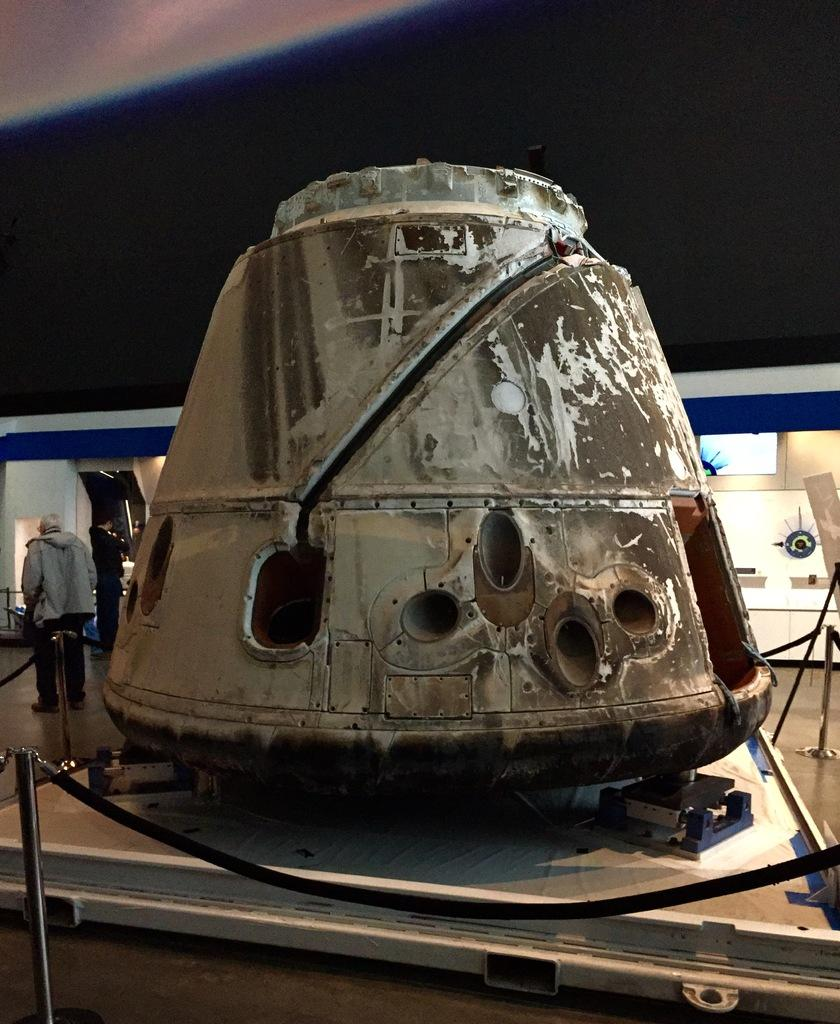What is the main object in the image? There is an object in the image, but its specific nature is not mentioned in the facts. Where is the object located? The object is on the floor. How many people are in the image? There are two persons standing on the floor. What can be seen in the background of the image? There are screens and a wall in the background of the image. What is the name of the pizzas being served in the image? There is no mention of pizzas in the image or the provided facts, so we cannot answer this question. 